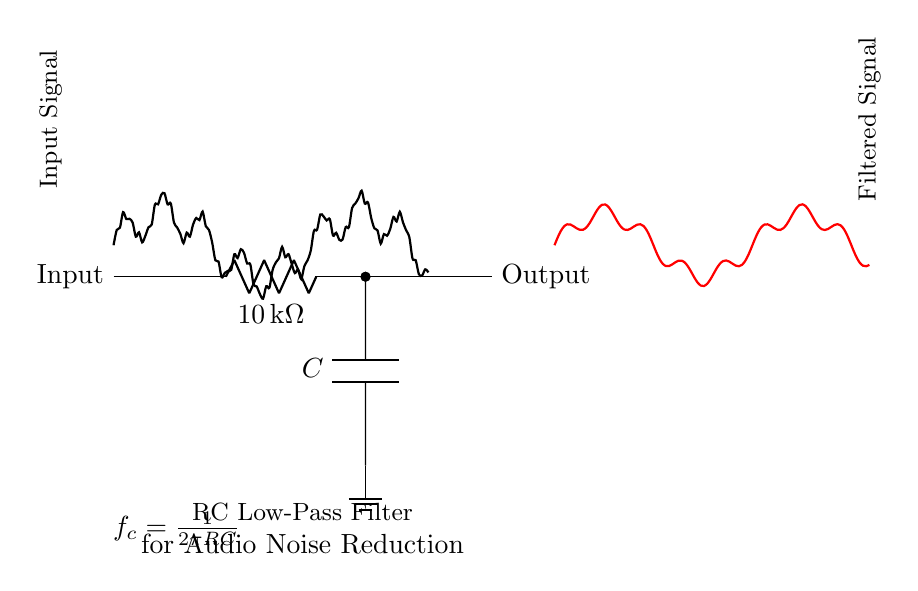What is the value of the resistor in the circuit? The resistor is labeled with a value of 10 kilohms in the circuit diagram.
Answer: 10 kilohms What component is used to reduce high frequency noise? The capacitor is the component that helps to reduce high frequency noise by filtering out unwanted signals.
Answer: Capacitor What is the cutoff frequency formula shown in the diagram? The cutoff frequency formula displayed in the diagram is f_c = 1/(2πRC). This formula indicates how the values of R and C determine the frequency at which the filter starts to reduce the amplitude of the signals.
Answer: f_c = 1/(2πRC) How does the input signal compare to the filtered output signal? The input signal is shown before it passes through the low-pass filter, while the output signal is the result after filtering. The output signal has reduced higher frequency components compared to the input signal.
Answer: Reduced high frequencies What is the primary function of the RC low-pass filter in audio applications? The primary function of the RC low-pass filter is to allow lower frequency audio signals to pass through while attenuating higher frequency noise, thus improving audio quality.
Answer: Noise reduction 